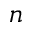Convert formula to latex. <formula><loc_0><loc_0><loc_500><loc_500>n</formula> 